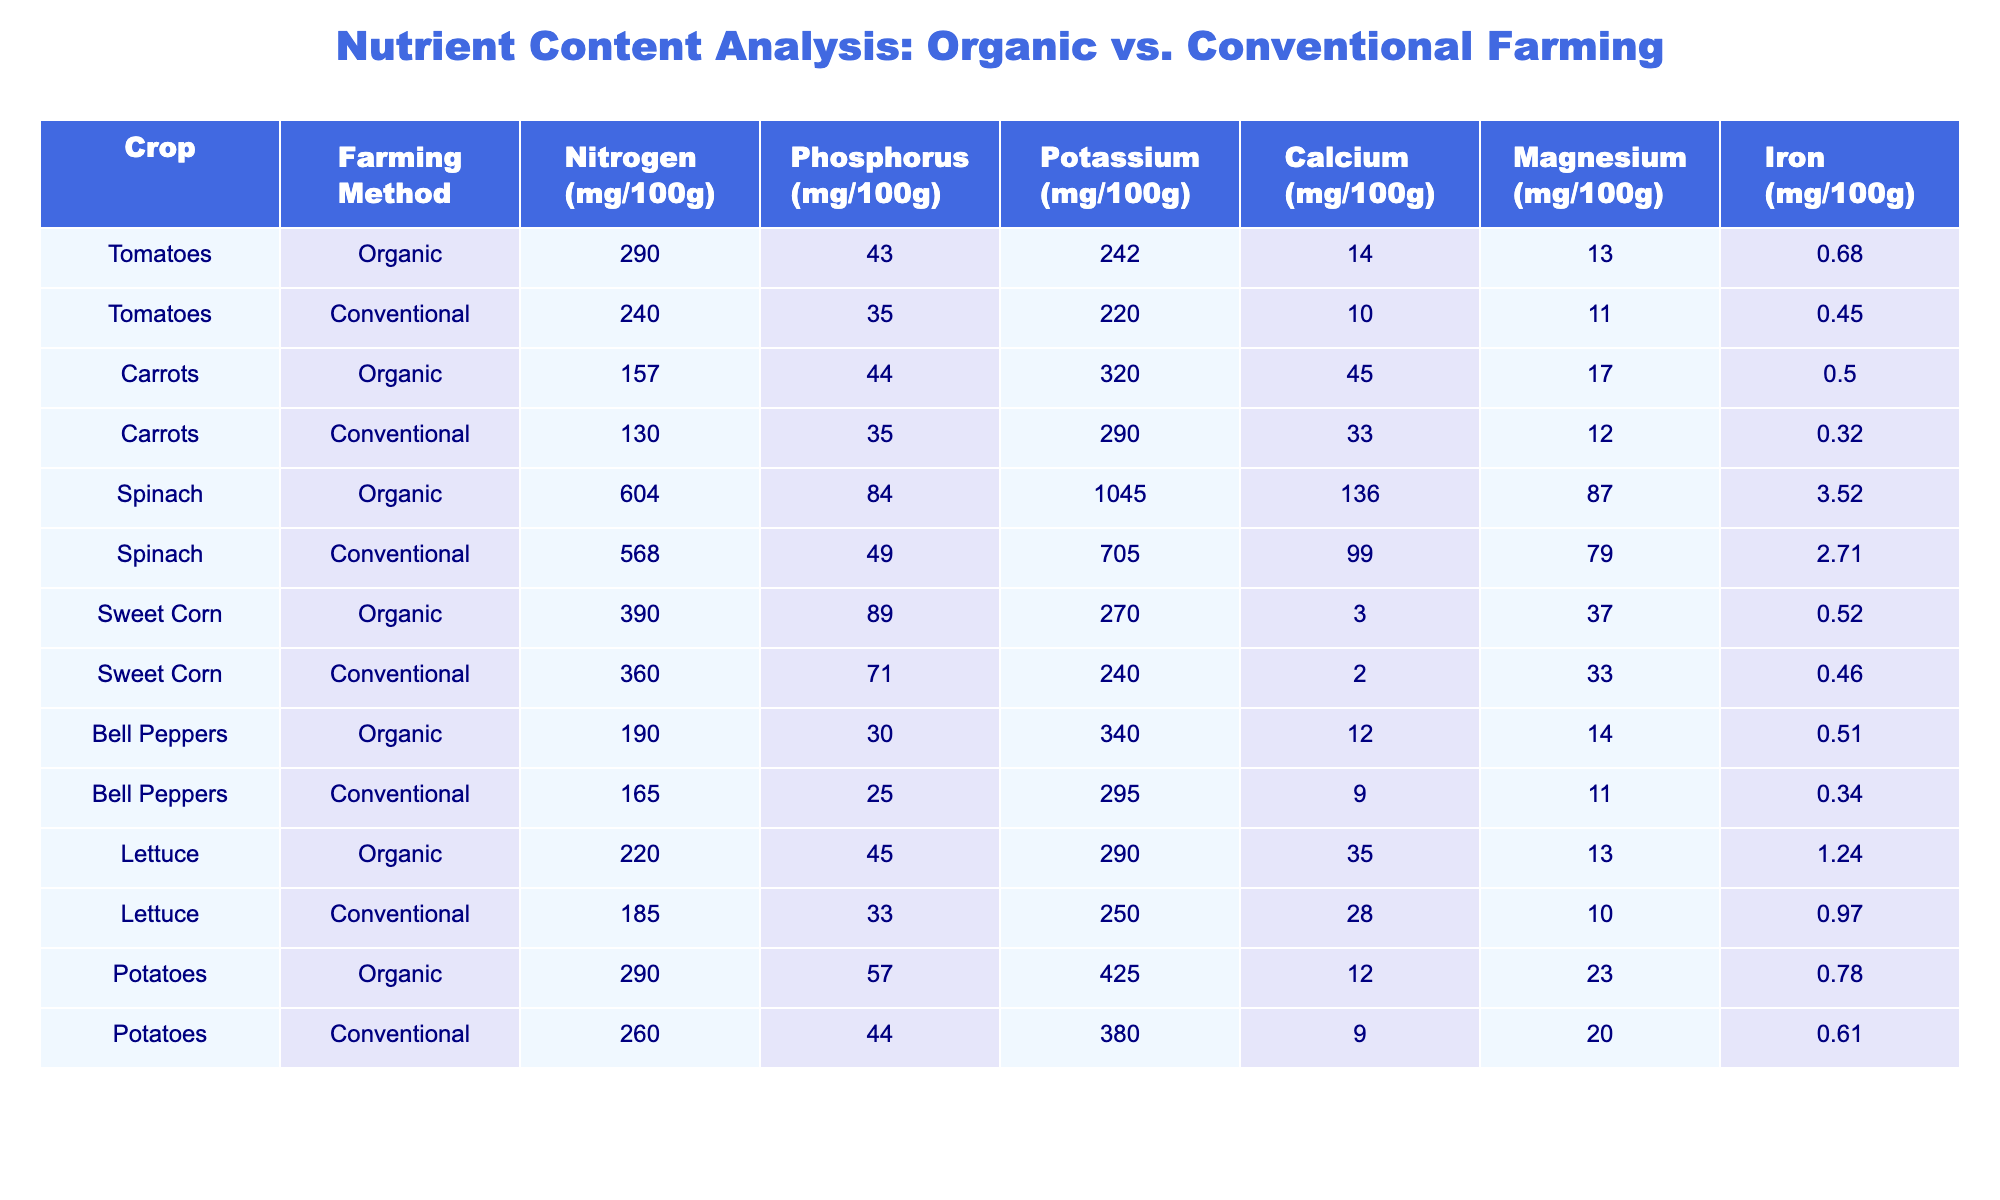What is the nitrogen content in organic tomatoes? Referring to the table under the crop "Tomatoes" and "Organic" farming method, the nitrogen content is listed as 290 mg/100g.
Answer: 290 mg/100g Which crop has the highest potassium content in organic farming? By examining the "Potassium (mg/100g)" column for the "Organic" farming method, we see that Spinach has the highest potassium content at 1045 mg/100g.
Answer: Spinach What is the difference in calcium content between organic and conventional carrots? Looking at the "Calcium (mg/100g)" for both the "Organic" (45 mg/100g) and "Conventional" (33 mg/100g) carrots, the difference is calculated as 45 - 33 = 12 mg/100g.
Answer: 12 mg/100g Is the phosphorus content in organic Sweet Corn higher than in conventional Sweet Corn? Checking the "Phosphorus (mg/100g)" for "Organic" (89 mg/100g) and "Conventional" (71 mg/100g) Sweet Corn reveals that 89 is greater than 71, confirming that organic Sweet Corn has higher phosphorus content.
Answer: Yes What is the average iron content across all organic crops listed? To find the average for "Iron (mg/100g)" in organic crops, we sum the values: 0.68 (Tomatoes) + 0.50 (Carrots) + 3.52 (Spinach) + 0.52 (Sweet Corn) + 0.51 (Bell Peppers) + 1.24 (Lettuce) + 0.78 (Potatoes) = 7.31 mg/100g. Then, divide by 7 (the number of crops): 7.31 / 7 = 1.04 mg/100g.
Answer: 1.04 mg/100g What is the iron content in conventional bell peppers and how does it compare with conventional potatoes? For "Bell Peppers" under "Conventional," the iron content is 0.34 mg/100g, and for "Potatoes," it is 0.61 mg/100g. Comparing these values, 0.61 > 0.34, thus conventional potatoes have a higher iron content.
Answer: 0.61 mg/100g 